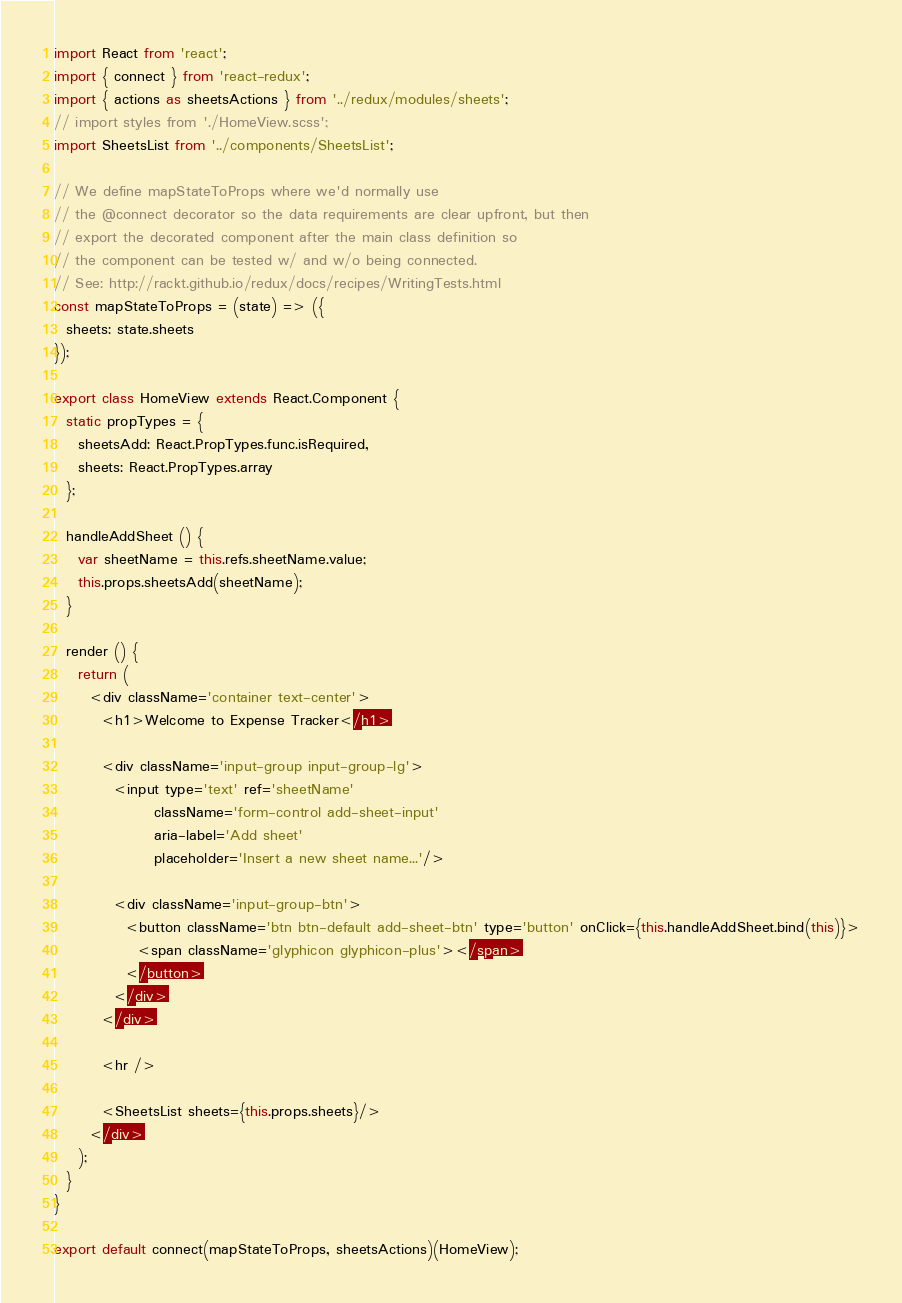Convert code to text. <code><loc_0><loc_0><loc_500><loc_500><_JavaScript_>import React from 'react';
import { connect } from 'react-redux';
import { actions as sheetsActions } from '../redux/modules/sheets';
// import styles from './HomeView.scss';
import SheetsList from '../components/SheetsList';

// We define mapStateToProps where we'd normally use
// the @connect decorator so the data requirements are clear upfront, but then
// export the decorated component after the main class definition so
// the component can be tested w/ and w/o being connected.
// See: http://rackt.github.io/redux/docs/recipes/WritingTests.html
const mapStateToProps = (state) => ({
  sheets: state.sheets
});

export class HomeView extends React.Component {
  static propTypes = {
    sheetsAdd: React.PropTypes.func.isRequired,
    sheets: React.PropTypes.array
  };

  handleAddSheet () {
    var sheetName = this.refs.sheetName.value;
    this.props.sheetsAdd(sheetName);
  }

  render () {
    return (
      <div className='container text-center'>
        <h1>Welcome to Expense Tracker</h1>

        <div className='input-group input-group-lg'>
          <input type='text' ref='sheetName'
                 className='form-control add-sheet-input'
                 aria-label='Add sheet'
                 placeholder='Insert a new sheet name...'/>

          <div className='input-group-btn'>
            <button className='btn btn-default add-sheet-btn' type='button' onClick={this.handleAddSheet.bind(this)}>
              <span className='glyphicon glyphicon-plus'></span>
            </button>
          </div>
        </div>

        <hr />

        <SheetsList sheets={this.props.sheets}/>
      </div>
    );
  }
}

export default connect(mapStateToProps, sheetsActions)(HomeView);
</code> 